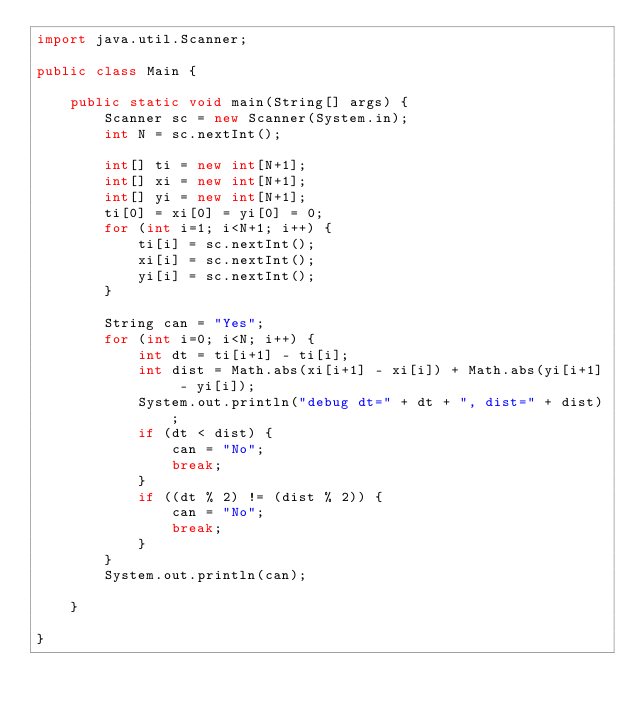Convert code to text. <code><loc_0><loc_0><loc_500><loc_500><_Java_>import java.util.Scanner;

public class Main {

	public static void main(String[] args) {
		Scanner sc = new Scanner(System.in);
		int N = sc.nextInt();

		int[] ti = new int[N+1];
		int[] xi = new int[N+1];
		int[] yi = new int[N+1];
		ti[0] = xi[0] = yi[0] = 0;
		for (int i=1; i<N+1; i++) {
			ti[i] = sc.nextInt();
			xi[i] = sc.nextInt();
			yi[i] = sc.nextInt();
		}

		String can = "Yes";
		for (int i=0; i<N; i++) {
			int dt = ti[i+1] - ti[i];
			int dist = Math.abs(xi[i+1] - xi[i]) + Math.abs(yi[i+1] - yi[i]);
			System.out.println("debug dt=" + dt + ", dist=" + dist);
			if (dt < dist) {
				can = "No";
				break;
			}
			if ((dt % 2) != (dist % 2)) {
				can = "No";
				break;
			}
		}
		System.out.println(can);

	}

}
</code> 